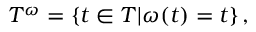<formula> <loc_0><loc_0><loc_500><loc_500>T ^ { \omega } = \{ t \in T | \omega ( t ) = t \} \, ,</formula> 